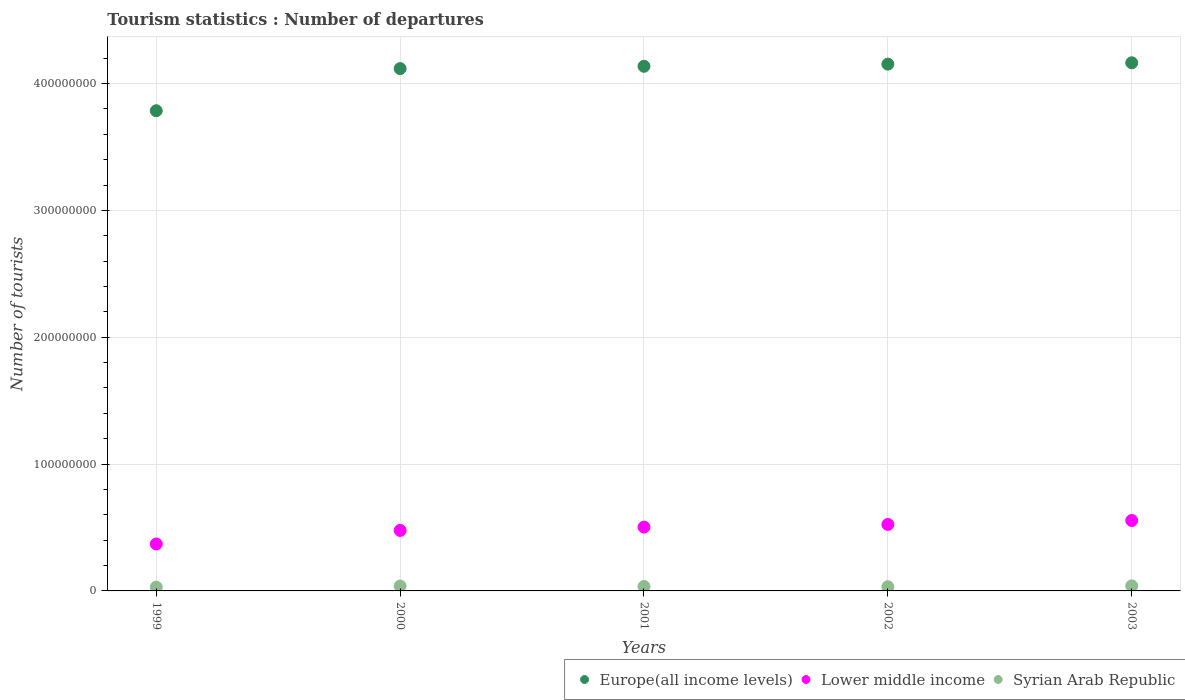How many different coloured dotlines are there?
Provide a succinct answer. 3. What is the number of tourist departures in Europe(all income levels) in 2001?
Your answer should be compact. 4.14e+08. Across all years, what is the maximum number of tourist departures in Syrian Arab Republic?
Ensure brevity in your answer.  4.00e+06. Across all years, what is the minimum number of tourist departures in Syrian Arab Republic?
Keep it short and to the point. 2.99e+06. In which year was the number of tourist departures in Europe(all income levels) maximum?
Your answer should be very brief. 2003. What is the total number of tourist departures in Lower middle income in the graph?
Your response must be concise. 2.43e+08. What is the difference between the number of tourist departures in Syrian Arab Republic in 2002 and that in 2003?
Offer a very short reply. -6.98e+05. What is the difference between the number of tourist departures in Syrian Arab Republic in 2003 and the number of tourist departures in Lower middle income in 2001?
Provide a succinct answer. -4.63e+07. What is the average number of tourist departures in Europe(all income levels) per year?
Your response must be concise. 4.07e+08. In the year 2000, what is the difference between the number of tourist departures in Lower middle income and number of tourist departures in Europe(all income levels)?
Your answer should be very brief. -3.64e+08. What is the ratio of the number of tourist departures in Lower middle income in 2001 to that in 2002?
Give a very brief answer. 0.96. What is the difference between the highest and the second highest number of tourist departures in Europe(all income levels)?
Keep it short and to the point. 1.05e+06. What is the difference between the highest and the lowest number of tourist departures in Lower middle income?
Your answer should be compact. 1.85e+07. In how many years, is the number of tourist departures in Syrian Arab Republic greater than the average number of tourist departures in Syrian Arab Republic taken over all years?
Provide a short and direct response. 2. Is the sum of the number of tourist departures in Lower middle income in 1999 and 2001 greater than the maximum number of tourist departures in Europe(all income levels) across all years?
Offer a terse response. No. Is it the case that in every year, the sum of the number of tourist departures in Syrian Arab Republic and number of tourist departures in Europe(all income levels)  is greater than the number of tourist departures in Lower middle income?
Your answer should be compact. Yes. Does the number of tourist departures in Lower middle income monotonically increase over the years?
Your response must be concise. Yes. Is the number of tourist departures in Europe(all income levels) strictly greater than the number of tourist departures in Syrian Arab Republic over the years?
Give a very brief answer. Yes. Is the number of tourist departures in Lower middle income strictly less than the number of tourist departures in Syrian Arab Republic over the years?
Provide a short and direct response. No. How many years are there in the graph?
Your answer should be compact. 5. Does the graph contain any zero values?
Provide a succinct answer. No. How many legend labels are there?
Make the answer very short. 3. What is the title of the graph?
Provide a succinct answer. Tourism statistics : Number of departures. Does "St. Lucia" appear as one of the legend labels in the graph?
Your answer should be very brief. No. What is the label or title of the X-axis?
Offer a very short reply. Years. What is the label or title of the Y-axis?
Give a very brief answer. Number of tourists. What is the Number of tourists of Europe(all income levels) in 1999?
Give a very brief answer. 3.79e+08. What is the Number of tourists of Lower middle income in 1999?
Give a very brief answer. 3.70e+07. What is the Number of tourists in Syrian Arab Republic in 1999?
Provide a succinct answer. 2.99e+06. What is the Number of tourists of Europe(all income levels) in 2000?
Your answer should be compact. 4.12e+08. What is the Number of tourists in Lower middle income in 2000?
Provide a succinct answer. 4.77e+07. What is the Number of tourists in Syrian Arab Republic in 2000?
Ensure brevity in your answer.  3.86e+06. What is the Number of tourists in Europe(all income levels) in 2001?
Provide a succinct answer. 4.14e+08. What is the Number of tourists of Lower middle income in 2001?
Give a very brief answer. 5.03e+07. What is the Number of tourists in Syrian Arab Republic in 2001?
Your answer should be very brief. 3.49e+06. What is the Number of tourists in Europe(all income levels) in 2002?
Your response must be concise. 4.15e+08. What is the Number of tourists in Lower middle income in 2002?
Offer a very short reply. 5.24e+07. What is the Number of tourists in Syrian Arab Republic in 2002?
Give a very brief answer. 3.30e+06. What is the Number of tourists of Europe(all income levels) in 2003?
Your response must be concise. 4.16e+08. What is the Number of tourists in Lower middle income in 2003?
Keep it short and to the point. 5.55e+07. What is the Number of tourists of Syrian Arab Republic in 2003?
Keep it short and to the point. 4.00e+06. Across all years, what is the maximum Number of tourists of Europe(all income levels)?
Your answer should be very brief. 4.16e+08. Across all years, what is the maximum Number of tourists of Lower middle income?
Your answer should be very brief. 5.55e+07. Across all years, what is the maximum Number of tourists of Syrian Arab Republic?
Provide a succinct answer. 4.00e+06. Across all years, what is the minimum Number of tourists in Europe(all income levels)?
Your answer should be compact. 3.79e+08. Across all years, what is the minimum Number of tourists of Lower middle income?
Your answer should be very brief. 3.70e+07. Across all years, what is the minimum Number of tourists in Syrian Arab Republic?
Ensure brevity in your answer.  2.99e+06. What is the total Number of tourists in Europe(all income levels) in the graph?
Provide a succinct answer. 2.04e+09. What is the total Number of tourists of Lower middle income in the graph?
Provide a short and direct response. 2.43e+08. What is the total Number of tourists in Syrian Arab Republic in the graph?
Offer a terse response. 1.76e+07. What is the difference between the Number of tourists in Europe(all income levels) in 1999 and that in 2000?
Offer a very short reply. -3.32e+07. What is the difference between the Number of tourists in Lower middle income in 1999 and that in 2000?
Offer a very short reply. -1.07e+07. What is the difference between the Number of tourists in Syrian Arab Republic in 1999 and that in 2000?
Your response must be concise. -8.69e+05. What is the difference between the Number of tourists of Europe(all income levels) in 1999 and that in 2001?
Provide a succinct answer. -3.50e+07. What is the difference between the Number of tourists of Lower middle income in 1999 and that in 2001?
Provide a short and direct response. -1.33e+07. What is the difference between the Number of tourists in Syrian Arab Republic in 1999 and that in 2001?
Provide a succinct answer. -4.98e+05. What is the difference between the Number of tourists in Europe(all income levels) in 1999 and that in 2002?
Your answer should be very brief. -3.67e+07. What is the difference between the Number of tourists in Lower middle income in 1999 and that in 2002?
Give a very brief answer. -1.54e+07. What is the difference between the Number of tourists in Syrian Arab Republic in 1999 and that in 2002?
Give a very brief answer. -3.05e+05. What is the difference between the Number of tourists of Europe(all income levels) in 1999 and that in 2003?
Offer a very short reply. -3.78e+07. What is the difference between the Number of tourists in Lower middle income in 1999 and that in 2003?
Offer a very short reply. -1.85e+07. What is the difference between the Number of tourists of Syrian Arab Republic in 1999 and that in 2003?
Make the answer very short. -1.00e+06. What is the difference between the Number of tourists of Europe(all income levels) in 2000 and that in 2001?
Your response must be concise. -1.81e+06. What is the difference between the Number of tourists in Lower middle income in 2000 and that in 2001?
Offer a very short reply. -2.63e+06. What is the difference between the Number of tourists in Syrian Arab Republic in 2000 and that in 2001?
Ensure brevity in your answer.  3.71e+05. What is the difference between the Number of tourists of Europe(all income levels) in 2000 and that in 2002?
Your answer should be compact. -3.51e+06. What is the difference between the Number of tourists of Lower middle income in 2000 and that in 2002?
Your response must be concise. -4.69e+06. What is the difference between the Number of tourists in Syrian Arab Republic in 2000 and that in 2002?
Offer a terse response. 5.64e+05. What is the difference between the Number of tourists of Europe(all income levels) in 2000 and that in 2003?
Give a very brief answer. -4.57e+06. What is the difference between the Number of tourists of Lower middle income in 2000 and that in 2003?
Offer a terse response. -7.81e+06. What is the difference between the Number of tourists of Syrian Arab Republic in 2000 and that in 2003?
Ensure brevity in your answer.  -1.34e+05. What is the difference between the Number of tourists in Europe(all income levels) in 2001 and that in 2002?
Make the answer very short. -1.70e+06. What is the difference between the Number of tourists of Lower middle income in 2001 and that in 2002?
Your answer should be compact. -2.07e+06. What is the difference between the Number of tourists of Syrian Arab Republic in 2001 and that in 2002?
Your answer should be compact. 1.93e+05. What is the difference between the Number of tourists in Europe(all income levels) in 2001 and that in 2003?
Provide a succinct answer. -2.76e+06. What is the difference between the Number of tourists in Lower middle income in 2001 and that in 2003?
Make the answer very short. -5.19e+06. What is the difference between the Number of tourists of Syrian Arab Republic in 2001 and that in 2003?
Make the answer very short. -5.05e+05. What is the difference between the Number of tourists in Europe(all income levels) in 2002 and that in 2003?
Your answer should be compact. -1.05e+06. What is the difference between the Number of tourists of Lower middle income in 2002 and that in 2003?
Give a very brief answer. -3.12e+06. What is the difference between the Number of tourists in Syrian Arab Republic in 2002 and that in 2003?
Offer a terse response. -6.98e+05. What is the difference between the Number of tourists in Europe(all income levels) in 1999 and the Number of tourists in Lower middle income in 2000?
Offer a very short reply. 3.31e+08. What is the difference between the Number of tourists in Europe(all income levels) in 1999 and the Number of tourists in Syrian Arab Republic in 2000?
Offer a very short reply. 3.75e+08. What is the difference between the Number of tourists of Lower middle income in 1999 and the Number of tourists of Syrian Arab Republic in 2000?
Your response must be concise. 3.31e+07. What is the difference between the Number of tourists in Europe(all income levels) in 1999 and the Number of tourists in Lower middle income in 2001?
Provide a succinct answer. 3.28e+08. What is the difference between the Number of tourists of Europe(all income levels) in 1999 and the Number of tourists of Syrian Arab Republic in 2001?
Give a very brief answer. 3.75e+08. What is the difference between the Number of tourists of Lower middle income in 1999 and the Number of tourists of Syrian Arab Republic in 2001?
Keep it short and to the point. 3.35e+07. What is the difference between the Number of tourists of Europe(all income levels) in 1999 and the Number of tourists of Lower middle income in 2002?
Keep it short and to the point. 3.26e+08. What is the difference between the Number of tourists of Europe(all income levels) in 1999 and the Number of tourists of Syrian Arab Republic in 2002?
Your answer should be very brief. 3.75e+08. What is the difference between the Number of tourists of Lower middle income in 1999 and the Number of tourists of Syrian Arab Republic in 2002?
Provide a succinct answer. 3.37e+07. What is the difference between the Number of tourists of Europe(all income levels) in 1999 and the Number of tourists of Lower middle income in 2003?
Keep it short and to the point. 3.23e+08. What is the difference between the Number of tourists in Europe(all income levels) in 1999 and the Number of tourists in Syrian Arab Republic in 2003?
Offer a terse response. 3.75e+08. What is the difference between the Number of tourists of Lower middle income in 1999 and the Number of tourists of Syrian Arab Republic in 2003?
Provide a succinct answer. 3.30e+07. What is the difference between the Number of tourists of Europe(all income levels) in 2000 and the Number of tourists of Lower middle income in 2001?
Keep it short and to the point. 3.61e+08. What is the difference between the Number of tourists of Europe(all income levels) in 2000 and the Number of tourists of Syrian Arab Republic in 2001?
Give a very brief answer. 4.08e+08. What is the difference between the Number of tourists in Lower middle income in 2000 and the Number of tourists in Syrian Arab Republic in 2001?
Your answer should be compact. 4.42e+07. What is the difference between the Number of tourists of Europe(all income levels) in 2000 and the Number of tourists of Lower middle income in 2002?
Your answer should be very brief. 3.59e+08. What is the difference between the Number of tourists in Europe(all income levels) in 2000 and the Number of tourists in Syrian Arab Republic in 2002?
Make the answer very short. 4.09e+08. What is the difference between the Number of tourists in Lower middle income in 2000 and the Number of tourists in Syrian Arab Republic in 2002?
Provide a short and direct response. 4.44e+07. What is the difference between the Number of tourists in Europe(all income levels) in 2000 and the Number of tourists in Lower middle income in 2003?
Offer a very short reply. 3.56e+08. What is the difference between the Number of tourists in Europe(all income levels) in 2000 and the Number of tourists in Syrian Arab Republic in 2003?
Make the answer very short. 4.08e+08. What is the difference between the Number of tourists in Lower middle income in 2000 and the Number of tourists in Syrian Arab Republic in 2003?
Give a very brief answer. 4.37e+07. What is the difference between the Number of tourists in Europe(all income levels) in 2001 and the Number of tourists in Lower middle income in 2002?
Offer a very short reply. 3.61e+08. What is the difference between the Number of tourists in Europe(all income levels) in 2001 and the Number of tourists in Syrian Arab Republic in 2002?
Provide a succinct answer. 4.10e+08. What is the difference between the Number of tourists of Lower middle income in 2001 and the Number of tourists of Syrian Arab Republic in 2002?
Keep it short and to the point. 4.70e+07. What is the difference between the Number of tourists of Europe(all income levels) in 2001 and the Number of tourists of Lower middle income in 2003?
Give a very brief answer. 3.58e+08. What is the difference between the Number of tourists of Europe(all income levels) in 2001 and the Number of tourists of Syrian Arab Republic in 2003?
Give a very brief answer. 4.10e+08. What is the difference between the Number of tourists of Lower middle income in 2001 and the Number of tourists of Syrian Arab Republic in 2003?
Make the answer very short. 4.63e+07. What is the difference between the Number of tourists of Europe(all income levels) in 2002 and the Number of tourists of Lower middle income in 2003?
Ensure brevity in your answer.  3.60e+08. What is the difference between the Number of tourists in Europe(all income levels) in 2002 and the Number of tourists in Syrian Arab Republic in 2003?
Offer a terse response. 4.11e+08. What is the difference between the Number of tourists of Lower middle income in 2002 and the Number of tourists of Syrian Arab Republic in 2003?
Make the answer very short. 4.84e+07. What is the average Number of tourists of Europe(all income levels) per year?
Your response must be concise. 4.07e+08. What is the average Number of tourists in Lower middle income per year?
Provide a short and direct response. 4.86e+07. What is the average Number of tourists in Syrian Arab Republic per year?
Your response must be concise. 3.53e+06. In the year 1999, what is the difference between the Number of tourists of Europe(all income levels) and Number of tourists of Lower middle income?
Ensure brevity in your answer.  3.42e+08. In the year 1999, what is the difference between the Number of tourists in Europe(all income levels) and Number of tourists in Syrian Arab Republic?
Your answer should be compact. 3.76e+08. In the year 1999, what is the difference between the Number of tourists of Lower middle income and Number of tourists of Syrian Arab Republic?
Your response must be concise. 3.40e+07. In the year 2000, what is the difference between the Number of tourists of Europe(all income levels) and Number of tourists of Lower middle income?
Make the answer very short. 3.64e+08. In the year 2000, what is the difference between the Number of tourists in Europe(all income levels) and Number of tourists in Syrian Arab Republic?
Provide a short and direct response. 4.08e+08. In the year 2000, what is the difference between the Number of tourists in Lower middle income and Number of tourists in Syrian Arab Republic?
Keep it short and to the point. 4.38e+07. In the year 2001, what is the difference between the Number of tourists of Europe(all income levels) and Number of tourists of Lower middle income?
Give a very brief answer. 3.63e+08. In the year 2001, what is the difference between the Number of tourists of Europe(all income levels) and Number of tourists of Syrian Arab Republic?
Your response must be concise. 4.10e+08. In the year 2001, what is the difference between the Number of tourists of Lower middle income and Number of tourists of Syrian Arab Republic?
Offer a very short reply. 4.68e+07. In the year 2002, what is the difference between the Number of tourists of Europe(all income levels) and Number of tourists of Lower middle income?
Provide a short and direct response. 3.63e+08. In the year 2002, what is the difference between the Number of tourists in Europe(all income levels) and Number of tourists in Syrian Arab Republic?
Ensure brevity in your answer.  4.12e+08. In the year 2002, what is the difference between the Number of tourists in Lower middle income and Number of tourists in Syrian Arab Republic?
Your answer should be compact. 4.91e+07. In the year 2003, what is the difference between the Number of tourists of Europe(all income levels) and Number of tourists of Lower middle income?
Your response must be concise. 3.61e+08. In the year 2003, what is the difference between the Number of tourists of Europe(all income levels) and Number of tourists of Syrian Arab Republic?
Keep it short and to the point. 4.12e+08. In the year 2003, what is the difference between the Number of tourists in Lower middle income and Number of tourists in Syrian Arab Republic?
Your answer should be very brief. 5.15e+07. What is the ratio of the Number of tourists in Europe(all income levels) in 1999 to that in 2000?
Make the answer very short. 0.92. What is the ratio of the Number of tourists in Lower middle income in 1999 to that in 2000?
Your answer should be compact. 0.78. What is the ratio of the Number of tourists in Syrian Arab Republic in 1999 to that in 2000?
Make the answer very short. 0.78. What is the ratio of the Number of tourists in Europe(all income levels) in 1999 to that in 2001?
Provide a short and direct response. 0.92. What is the ratio of the Number of tourists in Lower middle income in 1999 to that in 2001?
Offer a terse response. 0.74. What is the ratio of the Number of tourists in Syrian Arab Republic in 1999 to that in 2001?
Give a very brief answer. 0.86. What is the ratio of the Number of tourists in Europe(all income levels) in 1999 to that in 2002?
Your response must be concise. 0.91. What is the ratio of the Number of tourists in Lower middle income in 1999 to that in 2002?
Provide a short and direct response. 0.71. What is the ratio of the Number of tourists in Syrian Arab Republic in 1999 to that in 2002?
Your response must be concise. 0.91. What is the ratio of the Number of tourists in Europe(all income levels) in 1999 to that in 2003?
Provide a succinct answer. 0.91. What is the ratio of the Number of tourists in Lower middle income in 1999 to that in 2003?
Your answer should be compact. 0.67. What is the ratio of the Number of tourists of Syrian Arab Republic in 1999 to that in 2003?
Offer a terse response. 0.75. What is the ratio of the Number of tourists in Europe(all income levels) in 2000 to that in 2001?
Your answer should be compact. 1. What is the ratio of the Number of tourists in Lower middle income in 2000 to that in 2001?
Provide a succinct answer. 0.95. What is the ratio of the Number of tourists of Syrian Arab Republic in 2000 to that in 2001?
Provide a succinct answer. 1.11. What is the ratio of the Number of tourists in Lower middle income in 2000 to that in 2002?
Your answer should be compact. 0.91. What is the ratio of the Number of tourists in Syrian Arab Republic in 2000 to that in 2002?
Give a very brief answer. 1.17. What is the ratio of the Number of tourists of Europe(all income levels) in 2000 to that in 2003?
Offer a very short reply. 0.99. What is the ratio of the Number of tourists of Lower middle income in 2000 to that in 2003?
Make the answer very short. 0.86. What is the ratio of the Number of tourists of Syrian Arab Republic in 2000 to that in 2003?
Your answer should be compact. 0.97. What is the ratio of the Number of tourists in Europe(all income levels) in 2001 to that in 2002?
Keep it short and to the point. 1. What is the ratio of the Number of tourists in Lower middle income in 2001 to that in 2002?
Provide a short and direct response. 0.96. What is the ratio of the Number of tourists in Syrian Arab Republic in 2001 to that in 2002?
Your answer should be compact. 1.06. What is the ratio of the Number of tourists in Europe(all income levels) in 2001 to that in 2003?
Ensure brevity in your answer.  0.99. What is the ratio of the Number of tourists of Lower middle income in 2001 to that in 2003?
Give a very brief answer. 0.91. What is the ratio of the Number of tourists in Syrian Arab Republic in 2001 to that in 2003?
Give a very brief answer. 0.87. What is the ratio of the Number of tourists in Europe(all income levels) in 2002 to that in 2003?
Give a very brief answer. 1. What is the ratio of the Number of tourists in Lower middle income in 2002 to that in 2003?
Make the answer very short. 0.94. What is the ratio of the Number of tourists in Syrian Arab Republic in 2002 to that in 2003?
Offer a terse response. 0.83. What is the difference between the highest and the second highest Number of tourists in Europe(all income levels)?
Your answer should be compact. 1.05e+06. What is the difference between the highest and the second highest Number of tourists in Lower middle income?
Your response must be concise. 3.12e+06. What is the difference between the highest and the second highest Number of tourists in Syrian Arab Republic?
Your answer should be very brief. 1.34e+05. What is the difference between the highest and the lowest Number of tourists of Europe(all income levels)?
Your response must be concise. 3.78e+07. What is the difference between the highest and the lowest Number of tourists in Lower middle income?
Make the answer very short. 1.85e+07. What is the difference between the highest and the lowest Number of tourists of Syrian Arab Republic?
Make the answer very short. 1.00e+06. 